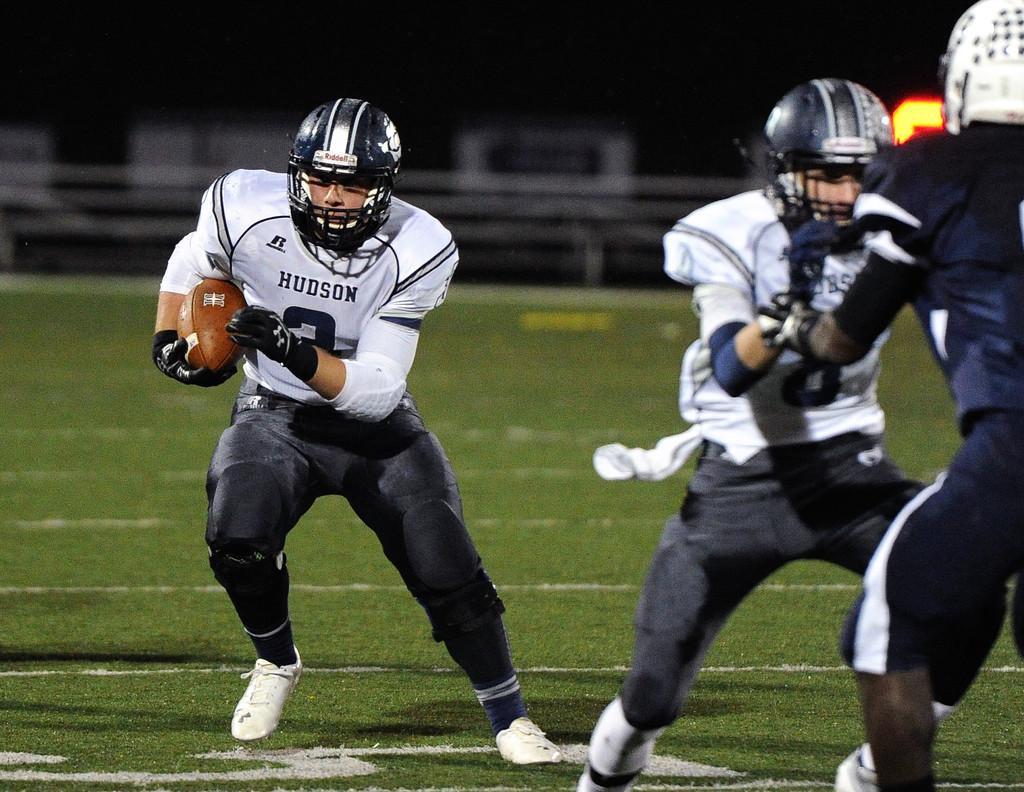How would you summarize this image in a sentence or two? This image consists of three men playing american football. They are wearing sports dress and helmets. At the bottom, there is green grass. The background is blurred. 